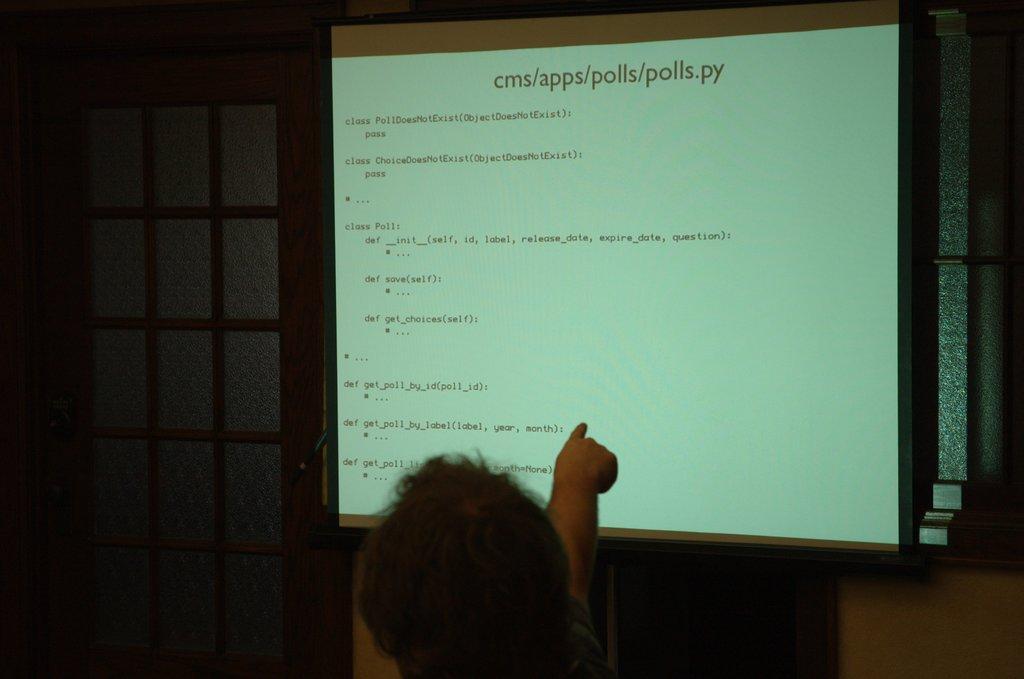Can you describe this image briefly? In this image there is a projector board. There is text on the board. At the bottom there is a person. In the background there are windows to the wall. 